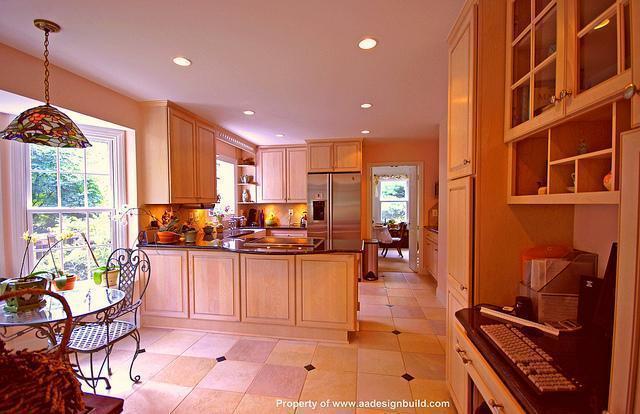What style of lamp is the one above the table?
Indicate the correct response and explain using: 'Answer: answer
Rationale: rationale.'
Options: Retro style, candle style, chandelier, tiffany style. Answer: tiffany style.
Rationale: It is a tiffany style because it has different colours with the stained class effect. What shape is the black tiles on the floor?
From the following set of four choices, select the accurate answer to respond to the question.
Options: Triangle, oval, square, diamond. Diamond. 